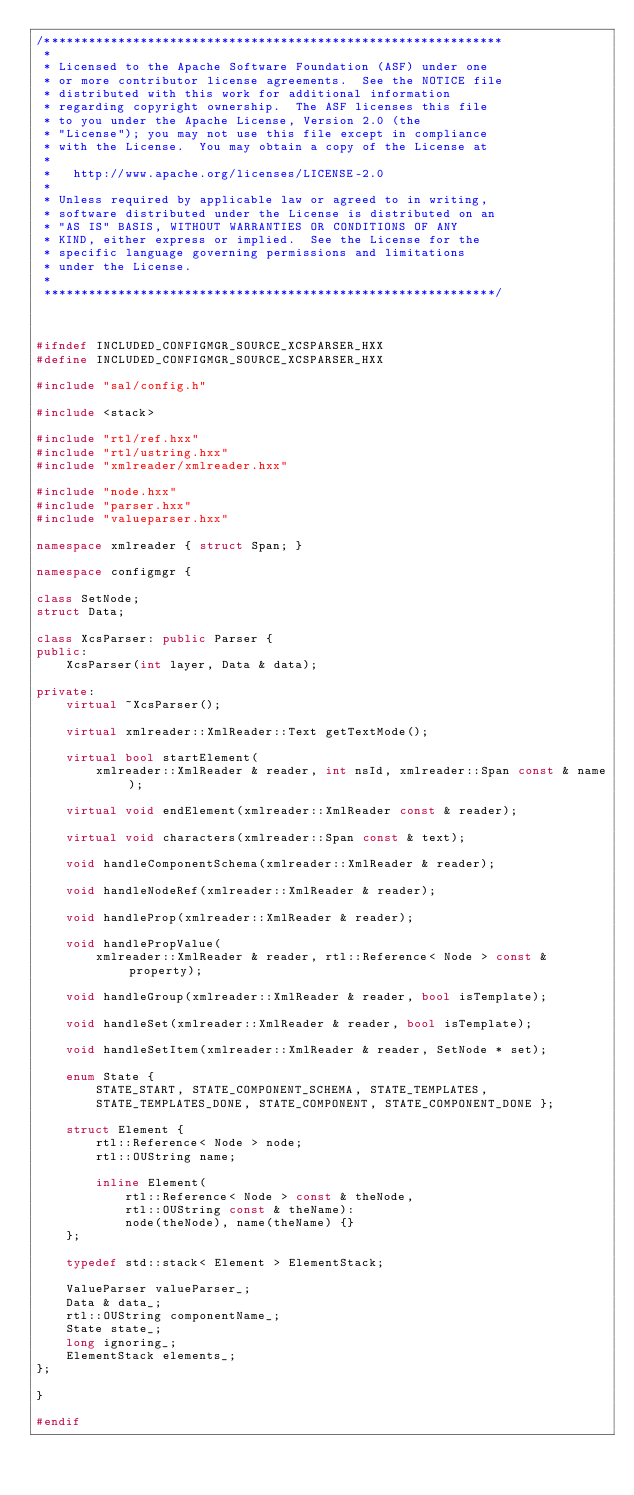<code> <loc_0><loc_0><loc_500><loc_500><_C++_>/**************************************************************
 * 
 * Licensed to the Apache Software Foundation (ASF) under one
 * or more contributor license agreements.  See the NOTICE file
 * distributed with this work for additional information
 * regarding copyright ownership.  The ASF licenses this file
 * to you under the Apache License, Version 2.0 (the
 * "License"); you may not use this file except in compliance
 * with the License.  You may obtain a copy of the License at
 * 
 *   http://www.apache.org/licenses/LICENSE-2.0
 * 
 * Unless required by applicable law or agreed to in writing,
 * software distributed under the License is distributed on an
 * "AS IS" BASIS, WITHOUT WARRANTIES OR CONDITIONS OF ANY
 * KIND, either express or implied.  See the License for the
 * specific language governing permissions and limitations
 * under the License.
 * 
 *************************************************************/



#ifndef INCLUDED_CONFIGMGR_SOURCE_XCSPARSER_HXX
#define INCLUDED_CONFIGMGR_SOURCE_XCSPARSER_HXX

#include "sal/config.h"

#include <stack>

#include "rtl/ref.hxx"
#include "rtl/ustring.hxx"
#include "xmlreader/xmlreader.hxx"

#include "node.hxx"
#include "parser.hxx"
#include "valueparser.hxx"

namespace xmlreader { struct Span; }

namespace configmgr {

class SetNode;
struct Data;

class XcsParser: public Parser {
public:
    XcsParser(int layer, Data & data);

private:
    virtual ~XcsParser();

    virtual xmlreader::XmlReader::Text getTextMode();

    virtual bool startElement(
        xmlreader::XmlReader & reader, int nsId, xmlreader::Span const & name);

    virtual void endElement(xmlreader::XmlReader const & reader);

    virtual void characters(xmlreader::Span const & text);

    void handleComponentSchema(xmlreader::XmlReader & reader);

    void handleNodeRef(xmlreader::XmlReader & reader);

    void handleProp(xmlreader::XmlReader & reader);

    void handlePropValue(
        xmlreader::XmlReader & reader, rtl::Reference< Node > const & property);

    void handleGroup(xmlreader::XmlReader & reader, bool isTemplate);

    void handleSet(xmlreader::XmlReader & reader, bool isTemplate);

    void handleSetItem(xmlreader::XmlReader & reader, SetNode * set);

    enum State {
        STATE_START, STATE_COMPONENT_SCHEMA, STATE_TEMPLATES,
        STATE_TEMPLATES_DONE, STATE_COMPONENT, STATE_COMPONENT_DONE };

    struct Element {
        rtl::Reference< Node > node;
        rtl::OUString name;

        inline Element(
            rtl::Reference< Node > const & theNode,
            rtl::OUString const & theName):
            node(theNode), name(theName) {}
    };

    typedef std::stack< Element > ElementStack;

    ValueParser valueParser_;
    Data & data_;
    rtl::OUString componentName_;
    State state_;
    long ignoring_;
    ElementStack elements_;
};

}

#endif
</code> 